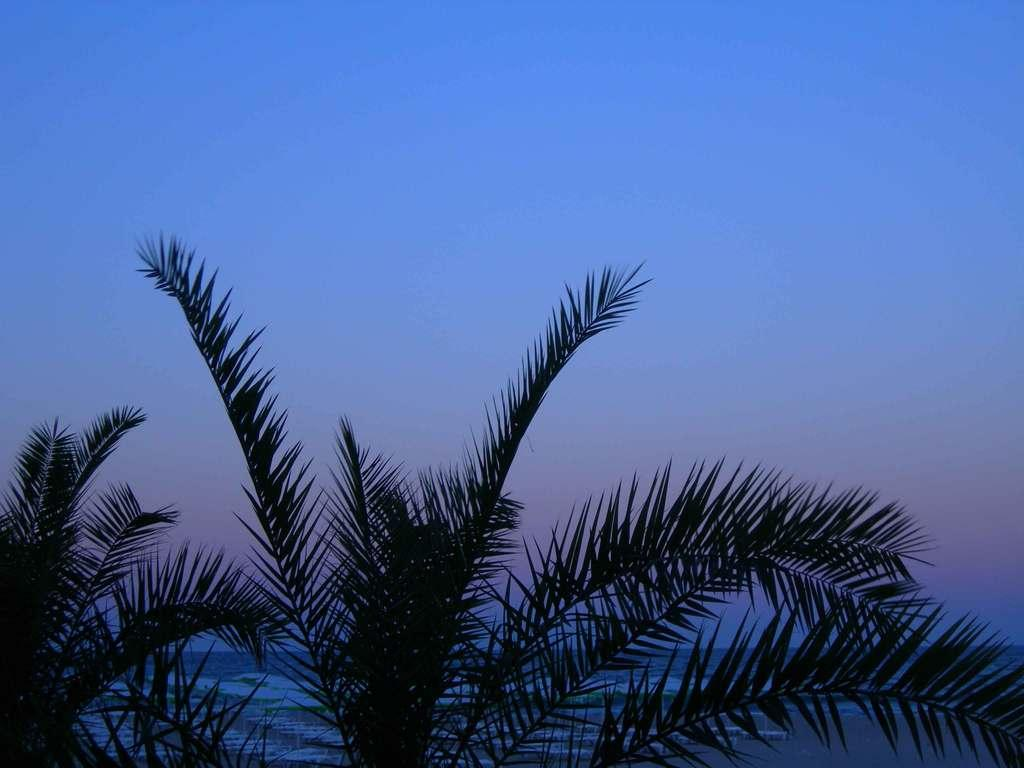What type of vegetation can be seen in the image? There are trees in the image. What can be seen in the background of the image? There is water visible in the background of the image. What is the weight of the stove in the image? There is no stove present in the image, so it is not possible to determine its weight. 